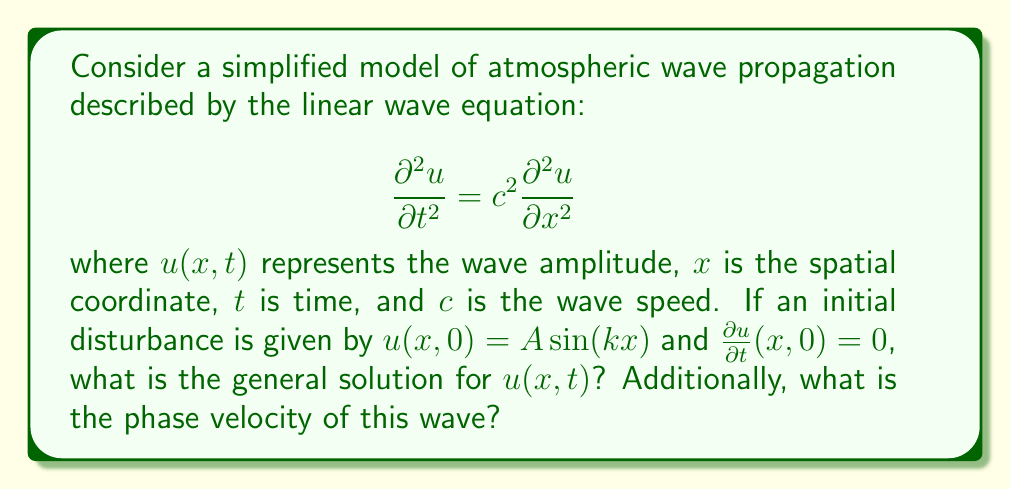Provide a solution to this math problem. To solve this problem, we'll follow these steps:

1) The general solution to the linear wave equation is given by d'Alembert's formula:

   $$u(x,t) = F(x-ct) + G(x+ct)$$

   where $F$ and $G$ are arbitrary functions determined by initial conditions.

2) Given the initial conditions:
   $u(x,0) = A \sin(kx)$
   $\frac{\partial u}{\partial t}(x,0) = 0$

3) From the first condition:
   $$F(x) + G(x) = A \sin(kx)$$

4) From the second condition:
   $$-cF'(x) + cG'(x) = 0$$
   This implies $F'(x) = G'(x)$

5) Integrating the result from step 4:
   $$F(x) = G(x) + constant$$

6) Combining with the result from step 3:
   $$2F(x) = A \sin(kx)$$
   $$F(x) = \frac{A}{2} \sin(kx)$$

7) Therefore, the general solution is:
   $$u(x,t) = \frac{A}{2} \sin(k(x-ct)) + \frac{A}{2} \sin(k(x+ct))$$

8) Using the trigonometric identity for the sum of sines, this can be written as:
   $$u(x,t) = A \sin(kx) \cos(kct)$$

9) The phase velocity is given by $v_p = \frac{\omega}{k}$, where $\omega$ is the angular frequency.
   From the solution, we can see that $\omega = kc$. Therefore:
   $$v_p = \frac{\omega}{k} = \frac{kc}{k} = c$$
Answer: $u(x,t) = A \sin(kx) \cos(kct)$; Phase velocity: $v_p = c$ 